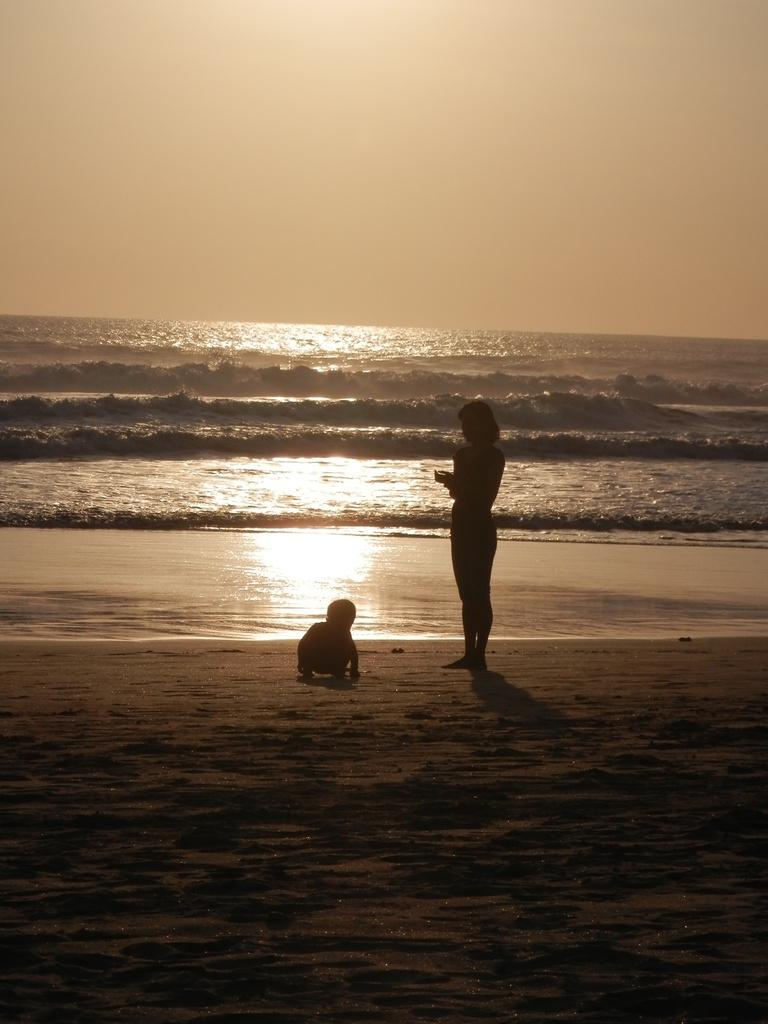Who is present in the image? There is a kid and a woman in the image. What is the setting of the image? Both the kid and woman are standing on the sand. What can be seen in the background of the image? There is water and the sky visible in the background. What type of rhythm can be heard from the curtain in the image? There is no curtain present in the image, and therefore no rhythm can be heard from it. 